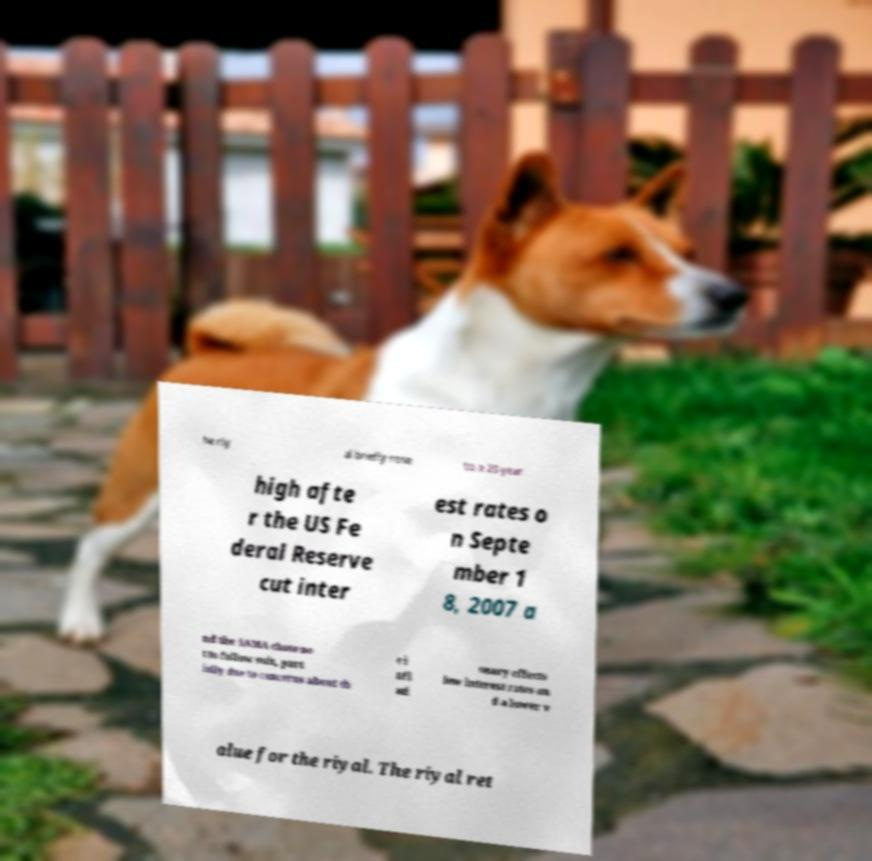Please read and relay the text visible in this image. What does it say? he riy al briefly rose to a 20-year high afte r the US Fe deral Reserve cut inter est rates o n Septe mber 1 8, 2007 a nd the SAMA chose no t to follow suit, part ially due to concerns about th e i nfl ati onary effects low interest rates an d a lower v alue for the riyal. The riyal ret 